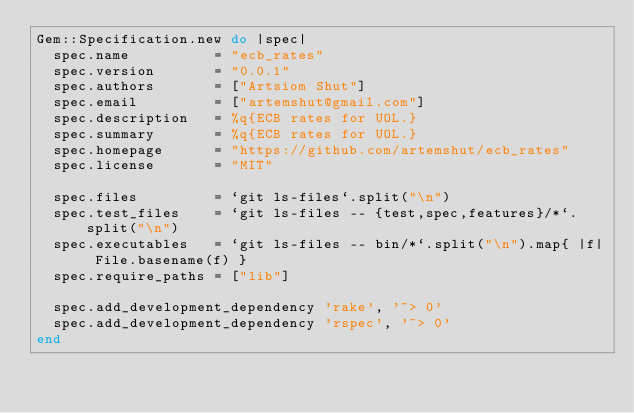<code> <loc_0><loc_0><loc_500><loc_500><_Ruby_>Gem::Specification.new do |spec|
  spec.name          = "ecb_rates"
  spec.version       = "0.0.1"
  spec.authors       = ["Artsiom Shut"]
  spec.email         = ["artemshut@gmail.com"]
  spec.description   = %q{ECB rates for UOL.}
  spec.summary       = %q{ECB rates for UOL.}
  spec.homepage      = "https://github.com/artemshut/ecb_rates"
  spec.license       = "MIT"

  spec.files         = `git ls-files`.split("\n")
  spec.test_files    = `git ls-files -- {test,spec,features}/*`.split("\n")
  spec.executables   = `git ls-files -- bin/*`.split("\n").map{ |f| File.basename(f) }
  spec.require_paths = ["lib"]

  spec.add_development_dependency 'rake', '~> 0'
  spec.add_development_dependency 'rspec', '~> 0'
end
</code> 